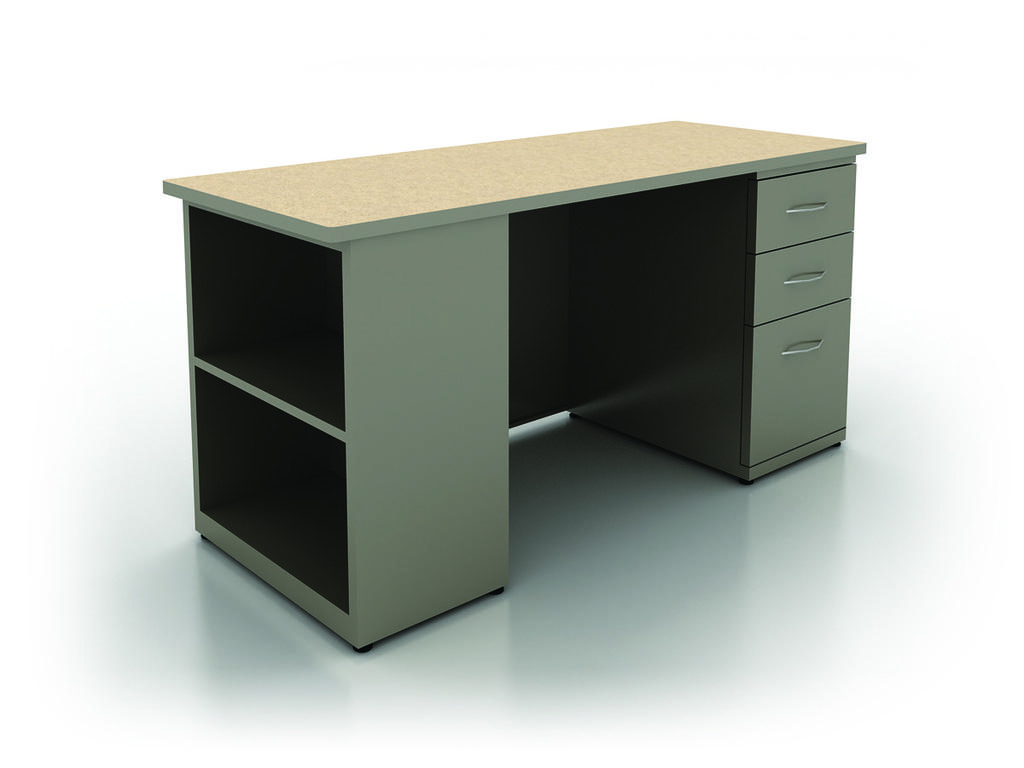What type of furniture is present in the image? There is a table in the image. What feature does the table have? The table has cupboards in it. What type of weather condition is depicted in the image? There is no weather condition depicted in the image; it only shows a table with cupboards. What kind of musical group is performing in the image? There is no musical group or performance present in the image; it only shows a table with cupboards. 